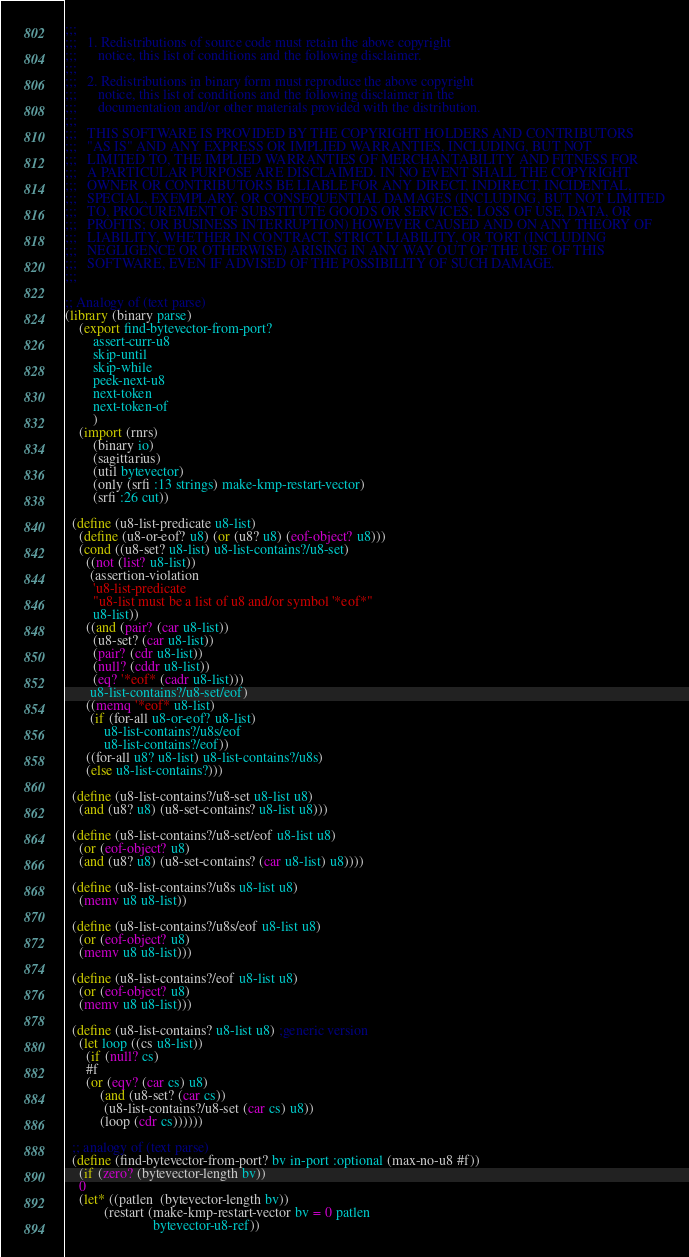<code> <loc_0><loc_0><loc_500><loc_500><_Scheme_>;;;   
;;;   1. Redistributions of source code must retain the above copyright
;;;      notice, this list of conditions and the following disclaimer.
;;;  
;;;   2. Redistributions in binary form must reproduce the above copyright
;;;      notice, this list of conditions and the following disclaimer in the
;;;      documentation and/or other materials provided with the distribution.
;;;  
;;;   THIS SOFTWARE IS PROVIDED BY THE COPYRIGHT HOLDERS AND CONTRIBUTORS
;;;   "AS IS" AND ANY EXPRESS OR IMPLIED WARRANTIES, INCLUDING, BUT NOT
;;;   LIMITED TO, THE IMPLIED WARRANTIES OF MERCHANTABILITY AND FITNESS FOR
;;;   A PARTICULAR PURPOSE ARE DISCLAIMED. IN NO EVENT SHALL THE COPYRIGHT
;;;   OWNER OR CONTRIBUTORS BE LIABLE FOR ANY DIRECT, INDIRECT, INCIDENTAL,
;;;   SPECIAL, EXEMPLARY, OR CONSEQUENTIAL DAMAGES (INCLUDING, BUT NOT LIMITED
;;;   TO, PROCUREMENT OF SUBSTITUTE GOODS OR SERVICES; LOSS OF USE, DATA, OR
;;;   PROFITS; OR BUSINESS INTERRUPTION) HOWEVER CAUSED AND ON ANY THEORY OF
;;;   LIABILITY, WHETHER IN CONTRACT, STRICT LIABILITY, OR TORT (INCLUDING
;;;   NEGLIGENCE OR OTHERWISE) ARISING IN ANY WAY OUT OF THE USE OF THIS
;;;   SOFTWARE, EVEN IF ADVISED OF THE POSSIBILITY OF SUCH DAMAGE.
;;;  

;; Analogy of (text parse)
(library (binary parse)
    (export find-bytevector-from-port?
	    assert-curr-u8
	    skip-until
	    skip-while
	    peek-next-u8
	    next-token
	    next-token-of
	    )
    (import (rnrs)
	    (binary io)
	    (sagittarius)
	    (util bytevector)
	    (only (srfi :13 strings) make-kmp-restart-vector)
	    (srfi :26 cut))
  
  (define (u8-list-predicate u8-list)
    (define (u8-or-eof? u8) (or (u8? u8) (eof-object? u8)))
    (cond ((u8-set? u8-list) u8-list-contains?/u8-set)
	  ((not (list? u8-list))
	   (assertion-violation 
	    'u8-list-predicate
	    "u8-list must be a list of u8 and/or symbol '*eof*"
	    u8-list))
	  ((and (pair? (car u8-list))
		(u8-set? (car u8-list))
		(pair? (cdr u8-list))
		(null? (cddr u8-list))
		(eq? '*eof* (cadr u8-list)))
	   u8-list-contains?/u8-set/eof)
	  ((memq '*eof* u8-list)
	   (if (for-all u8-or-eof? u8-list)
	       u8-list-contains?/u8s/eof
	       u8-list-contains?/eof))
	  ((for-all u8? u8-list) u8-list-contains?/u8s)
	  (else u8-list-contains?)))

  (define (u8-list-contains?/u8-set u8-list u8)
    (and (u8? u8) (u8-set-contains? u8-list u8)))

  (define (u8-list-contains?/u8-set/eof u8-list u8)
    (or (eof-object? u8)
	(and (u8? u8) (u8-set-contains? (car u8-list) u8))))

  (define (u8-list-contains?/u8s u8-list u8)
    (memv u8 u8-list))

  (define (u8-list-contains?/u8s/eof u8-list u8)
    (or (eof-object? u8)
	(memv u8 u8-list)))

  (define (u8-list-contains?/eof u8-list u8)
    (or (eof-object? u8)
	(memv u8 u8-list)))

  (define (u8-list-contains? u8-list u8) ;generic version
    (let loop ((cs u8-list))
      (if (null? cs)
	  #f
	  (or (eqv? (car cs) u8)
	      (and (u8-set? (car cs))
		   (u8-list-contains?/u8-set (car cs) u8))
	      (loop (cdr cs))))))

  ;; analogy of (text parse)
  (define (find-bytevector-from-port? bv in-port :optional (max-no-u8 #f))
    (if (zero? (bytevector-length bv))
	0
	(let* ((patlen  (bytevector-length bv))
	       (restart (make-kmp-restart-vector bv = 0 patlen
						 bytevector-u8-ref))</code> 